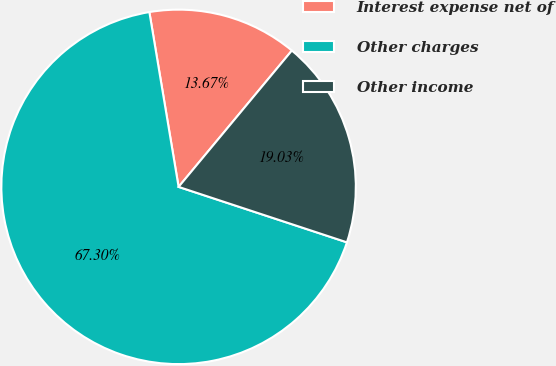<chart> <loc_0><loc_0><loc_500><loc_500><pie_chart><fcel>Interest expense net of<fcel>Other charges<fcel>Other income<nl><fcel>13.67%<fcel>67.29%<fcel>19.03%<nl></chart> 